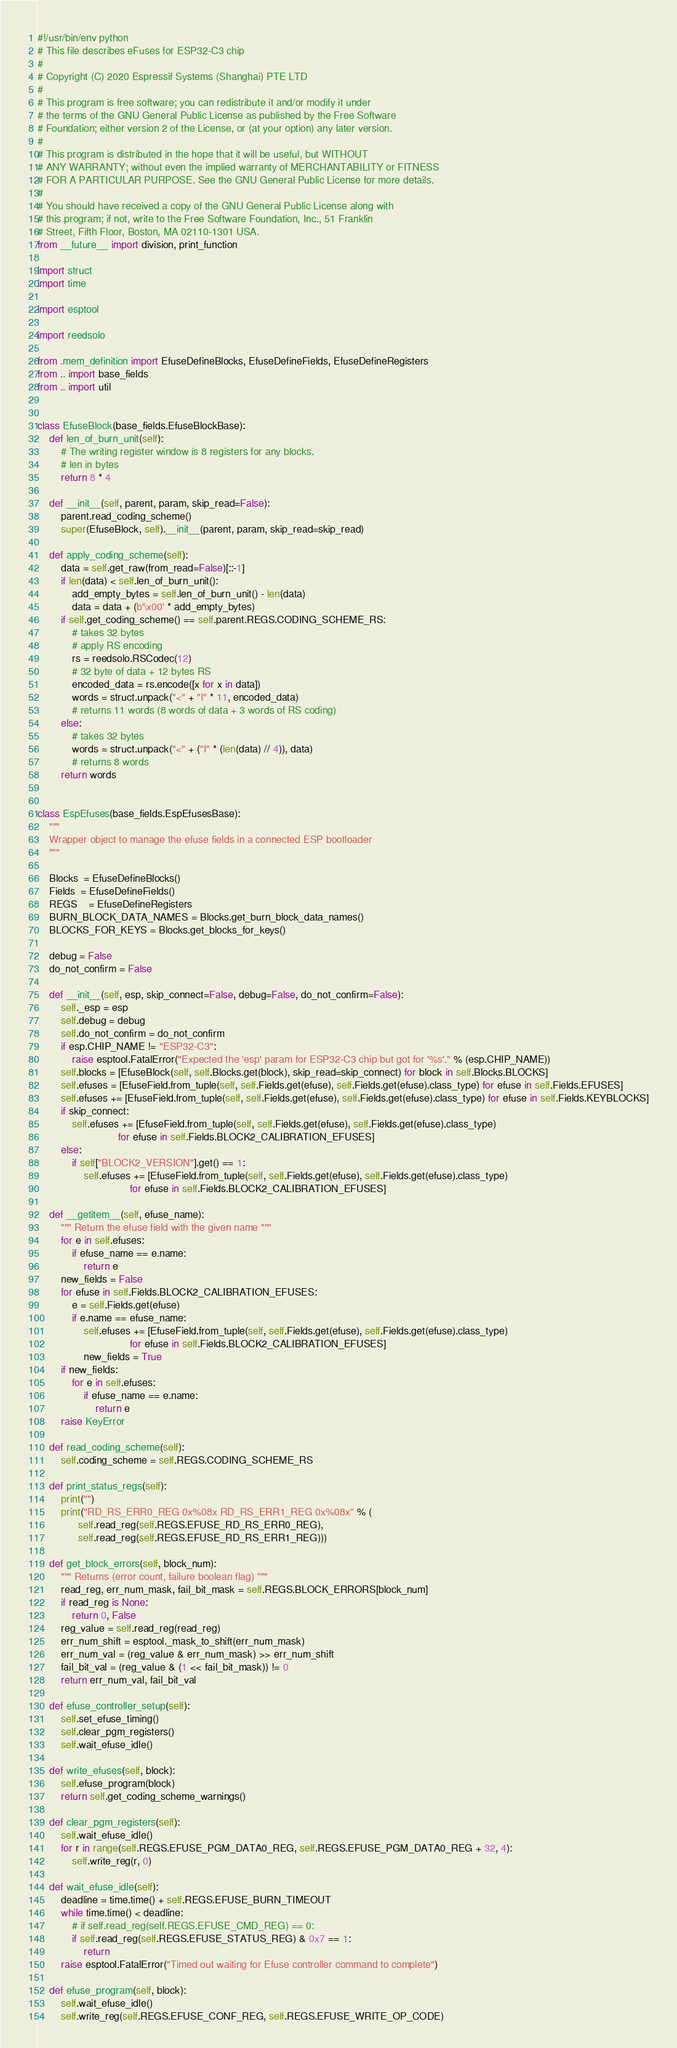Convert code to text. <code><loc_0><loc_0><loc_500><loc_500><_Python_>#!/usr/bin/env python
# This file describes eFuses for ESP32-C3 chip
#
# Copyright (C) 2020 Espressif Systems (Shanghai) PTE LTD
#
# This program is free software; you can redistribute it and/or modify it under
# the terms of the GNU General Public License as published by the Free Software
# Foundation; either version 2 of the License, or (at your option) any later version.
#
# This program is distributed in the hope that it will be useful, but WITHOUT
# ANY WARRANTY; without even the implied warranty of MERCHANTABILITY or FITNESS
# FOR A PARTICULAR PURPOSE. See the GNU General Public License for more details.
#
# You should have received a copy of the GNU General Public License along with
# this program; if not, write to the Free Software Foundation, Inc., 51 Franklin
# Street, Fifth Floor, Boston, MA 02110-1301 USA.
from __future__ import division, print_function

import struct
import time

import esptool

import reedsolo

from .mem_definition import EfuseDefineBlocks, EfuseDefineFields, EfuseDefineRegisters
from .. import base_fields
from .. import util


class EfuseBlock(base_fields.EfuseBlockBase):
    def len_of_burn_unit(self):
        # The writing register window is 8 registers for any blocks.
        # len in bytes
        return 8 * 4

    def __init__(self, parent, param, skip_read=False):
        parent.read_coding_scheme()
        super(EfuseBlock, self).__init__(parent, param, skip_read=skip_read)

    def apply_coding_scheme(self):
        data = self.get_raw(from_read=False)[::-1]
        if len(data) < self.len_of_burn_unit():
            add_empty_bytes = self.len_of_burn_unit() - len(data)
            data = data + (b'\x00' * add_empty_bytes)
        if self.get_coding_scheme() == self.parent.REGS.CODING_SCHEME_RS:
            # takes 32 bytes
            # apply RS encoding
            rs = reedsolo.RSCodec(12)
            # 32 byte of data + 12 bytes RS
            encoded_data = rs.encode([x for x in data])
            words = struct.unpack("<" + "I" * 11, encoded_data)
            # returns 11 words (8 words of data + 3 words of RS coding)
        else:
            # takes 32 bytes
            words = struct.unpack("<" + ("I" * (len(data) // 4)), data)
            # returns 8 words
        return words


class EspEfuses(base_fields.EspEfusesBase):
    """
    Wrapper object to manage the efuse fields in a connected ESP bootloader
    """

    Blocks  = EfuseDefineBlocks()
    Fields  = EfuseDefineFields()
    REGS    = EfuseDefineRegisters
    BURN_BLOCK_DATA_NAMES = Blocks.get_burn_block_data_names()
    BLOCKS_FOR_KEYS = Blocks.get_blocks_for_keys()

    debug = False
    do_not_confirm = False

    def __init__(self, esp, skip_connect=False, debug=False, do_not_confirm=False):
        self._esp = esp
        self.debug = debug
        self.do_not_confirm = do_not_confirm
        if esp.CHIP_NAME != "ESP32-C3":
            raise esptool.FatalError("Expected the 'esp' param for ESP32-C3 chip but got for '%s'." % (esp.CHIP_NAME))
        self.blocks = [EfuseBlock(self, self.Blocks.get(block), skip_read=skip_connect) for block in self.Blocks.BLOCKS]
        self.efuses = [EfuseField.from_tuple(self, self.Fields.get(efuse), self.Fields.get(efuse).class_type) for efuse in self.Fields.EFUSES]
        self.efuses += [EfuseField.from_tuple(self, self.Fields.get(efuse), self.Fields.get(efuse).class_type) for efuse in self.Fields.KEYBLOCKS]
        if skip_connect:
            self.efuses += [EfuseField.from_tuple(self, self.Fields.get(efuse), self.Fields.get(efuse).class_type)
                            for efuse in self.Fields.BLOCK2_CALIBRATION_EFUSES]
        else:
            if self["BLOCK2_VERSION"].get() == 1:
                self.efuses += [EfuseField.from_tuple(self, self.Fields.get(efuse), self.Fields.get(efuse).class_type)
                                for efuse in self.Fields.BLOCK2_CALIBRATION_EFUSES]

    def __getitem__(self, efuse_name):
        """ Return the efuse field with the given name """
        for e in self.efuses:
            if efuse_name == e.name:
                return e
        new_fields = False
        for efuse in self.Fields.BLOCK2_CALIBRATION_EFUSES:
            e = self.Fields.get(efuse)
            if e.name == efuse_name:
                self.efuses += [EfuseField.from_tuple(self, self.Fields.get(efuse), self.Fields.get(efuse).class_type)
                                for efuse in self.Fields.BLOCK2_CALIBRATION_EFUSES]
                new_fields = True
        if new_fields:
            for e in self.efuses:
                if efuse_name == e.name:
                    return e
        raise KeyError

    def read_coding_scheme(self):
        self.coding_scheme = self.REGS.CODING_SCHEME_RS

    def print_status_regs(self):
        print("")
        print("RD_RS_ERR0_REG 0x%08x RD_RS_ERR1_REG 0x%08x" % (
              self.read_reg(self.REGS.EFUSE_RD_RS_ERR0_REG),
              self.read_reg(self.REGS.EFUSE_RD_RS_ERR1_REG)))

    def get_block_errors(self, block_num):
        """ Returns (error count, failure boolean flag) """
        read_reg, err_num_mask, fail_bit_mask = self.REGS.BLOCK_ERRORS[block_num]
        if read_reg is None:
            return 0, False
        reg_value = self.read_reg(read_reg)
        err_num_shift = esptool._mask_to_shift(err_num_mask)
        err_num_val = (reg_value & err_num_mask) >> err_num_shift
        fail_bit_val = (reg_value & (1 << fail_bit_mask)) != 0
        return err_num_val, fail_bit_val

    def efuse_controller_setup(self):
        self.set_efuse_timing()
        self.clear_pgm_registers()
        self.wait_efuse_idle()

    def write_efuses(self, block):
        self.efuse_program(block)
        return self.get_coding_scheme_warnings()

    def clear_pgm_registers(self):
        self.wait_efuse_idle()
        for r in range(self.REGS.EFUSE_PGM_DATA0_REG, self.REGS.EFUSE_PGM_DATA0_REG + 32, 4):
            self.write_reg(r, 0)

    def wait_efuse_idle(self):
        deadline = time.time() + self.REGS.EFUSE_BURN_TIMEOUT
        while time.time() < deadline:
            # if self.read_reg(self.REGS.EFUSE_CMD_REG) == 0:
            if self.read_reg(self.REGS.EFUSE_STATUS_REG) & 0x7 == 1:
                return
        raise esptool.FatalError("Timed out waiting for Efuse controller command to complete")

    def efuse_program(self, block):
        self.wait_efuse_idle()
        self.write_reg(self.REGS.EFUSE_CONF_REG, self.REGS.EFUSE_WRITE_OP_CODE)</code> 